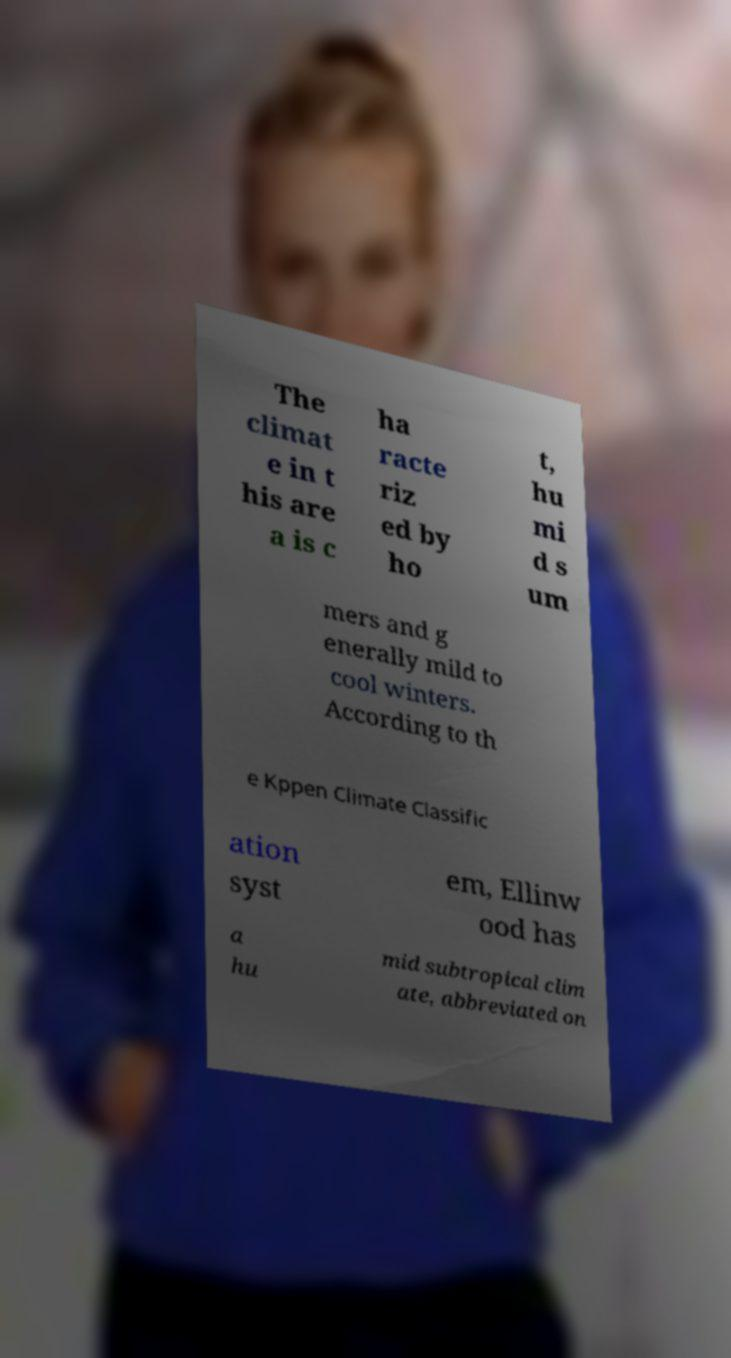There's text embedded in this image that I need extracted. Can you transcribe it verbatim? The climat e in t his are a is c ha racte riz ed by ho t, hu mi d s um mers and g enerally mild to cool winters. According to th e Kppen Climate Classific ation syst em, Ellinw ood has a hu mid subtropical clim ate, abbreviated on 